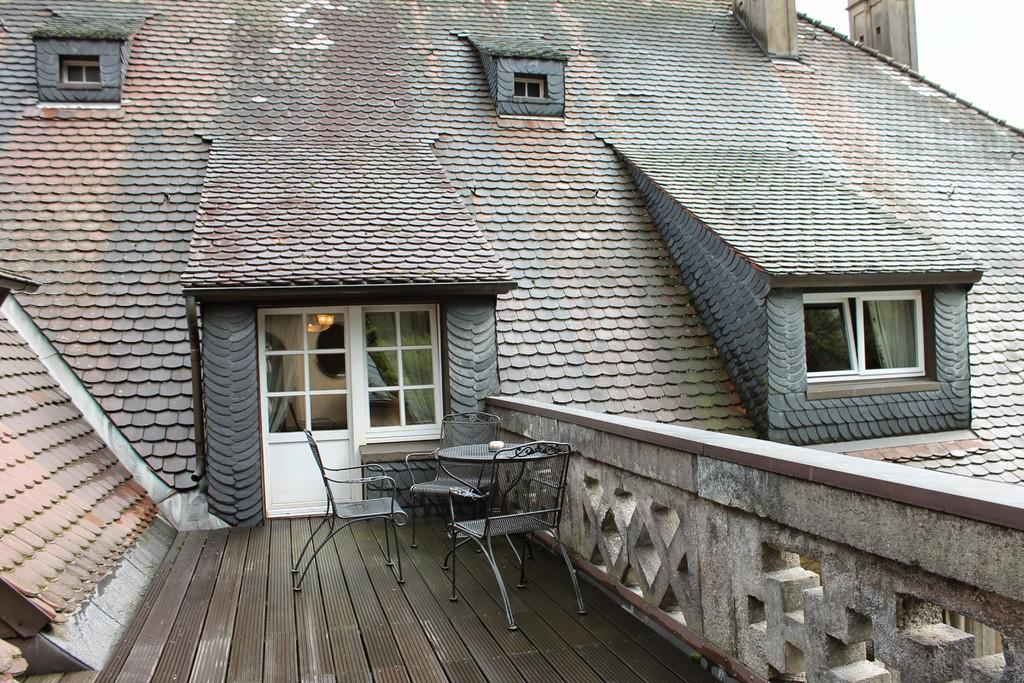What type of structure is the main subject in the image? There is a big building in the image. What feature can be seen on the building? The building has glass doors and windows. Where are tables and chairs located in the image? Tables and chairs are at the balcony in the image. How many pieces of pie are on the balcony in the image? There is no pie present in the image. What type of lizards can be seen crawling on the building in the image? There are no lizards present in the image. 